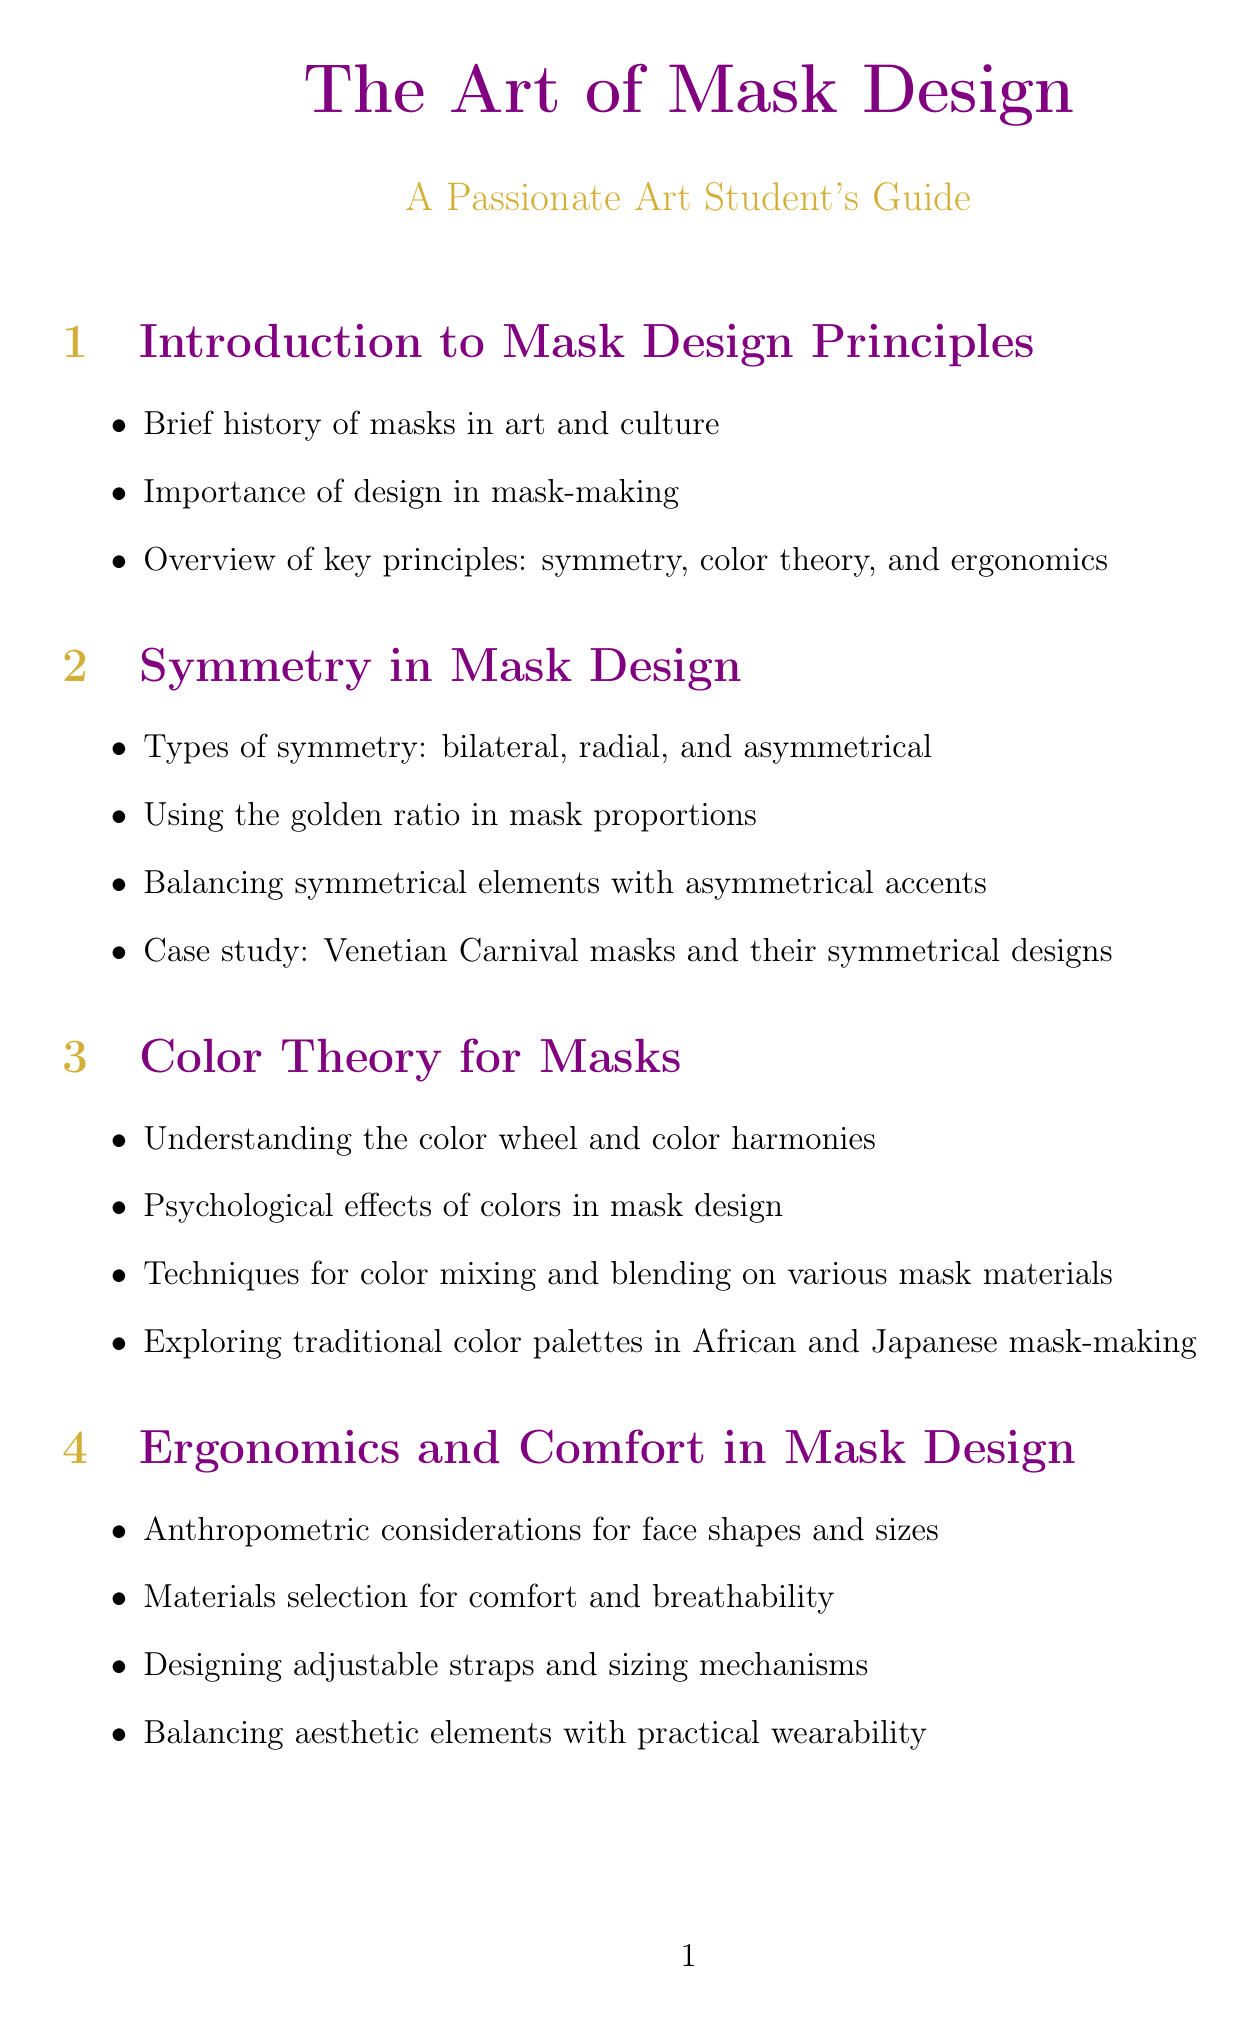What are the three key principles in mask design? The three key principles in mask design are mentioned in the introduction section of the document.
Answer: symmetry, color theory, and ergonomics What are the types of symmetry discussed? The types of symmetry are listed in the section on symmetry in mask design.
Answer: bilateral, radial, and asymmetrical What is the importance of the golden ratio in mask design? The document explains the application of the golden ratio specifically in mask proportions in the symmetry section.
Answer: mask proportions Which traditional color palettes are explored? The section on color theory for masks lists the traditional color palettes that are discussed.
Answer: African and Japanese What ergonomic considerations are mentioned? The ergonomics section addresses specific considerations for face shapes and sizes.
Answer: face shapes and sizes What techniques are suggested for color mixing? The techniques for color mixing and blending are outlined in the color theory section of the document.
Answer: color mixing and blending What is covered under advanced techniques in mask design? The advanced techniques section specifies new methods incorporated into mask design.
Answer: mixed media and found objects What should be included in an artist statement? The document mentions what to create for showcasing mask designs, including an artist statement.
Answer: artist statement What should be researched to avoid cultural appropriation? The cultural sensitivity section advises on researching certain aspects to prevent cultural appropriation.
Answer: cultural significance of masks 